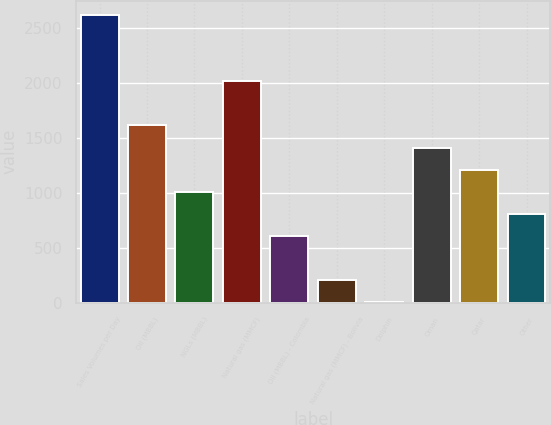<chart> <loc_0><loc_0><loc_500><loc_500><bar_chart><fcel>Sales Volumes per Day<fcel>Oil (MBBL)<fcel>NGLs (MBBL)<fcel>Natural gas (MMCF)<fcel>Oil (MBBL) - Colombia<fcel>Natural gas (MMCF) - Bolivia<fcel>Dolphin<fcel>Oman<fcel>Qatar<fcel>Other<nl><fcel>2615.1<fcel>1611.6<fcel>1009.5<fcel>2013<fcel>608.1<fcel>206.7<fcel>6<fcel>1410.9<fcel>1210.2<fcel>808.8<nl></chart> 